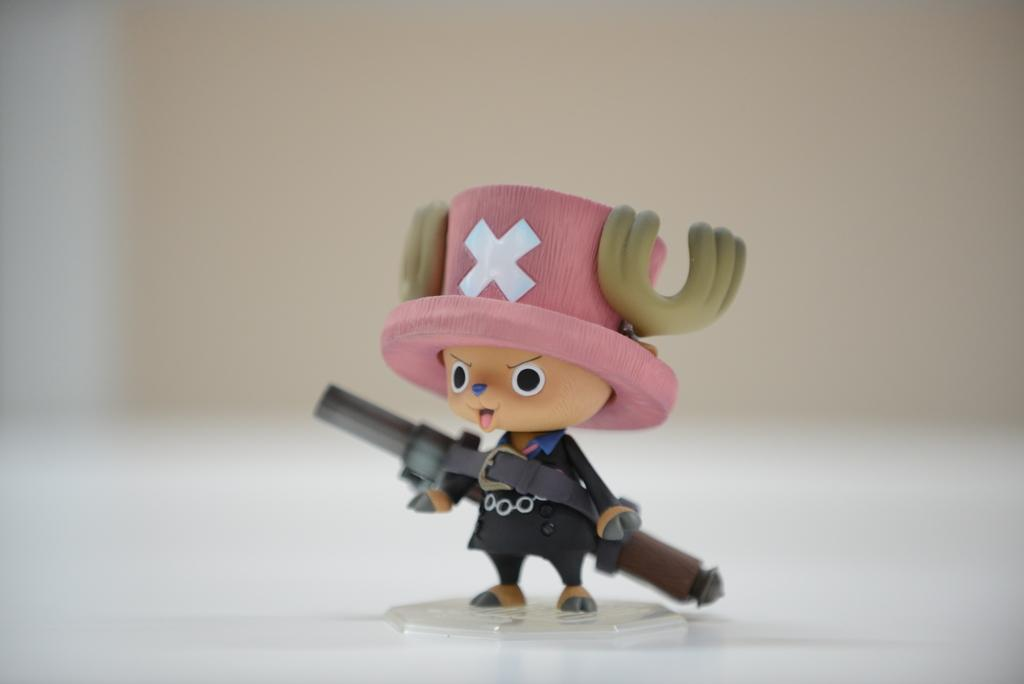What object can be seen in the image? There is a toy in the image. What is the toy holding? The toy is holding a gun. Can you describe the background of the image? The background of the image is blurred. Where is the parcel located in the image? There is no parcel present in the image. What type of receipt can be seen in the image? There is no receipt present in the image. 